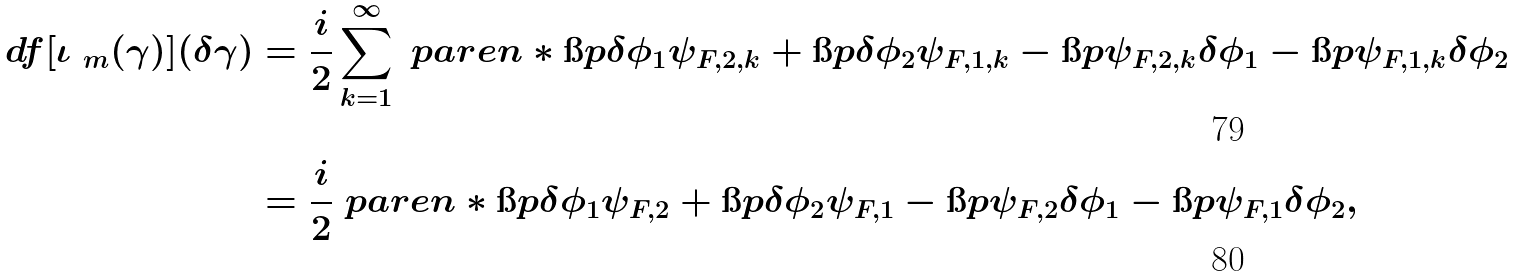Convert formula to latex. <formula><loc_0><loc_0><loc_500><loc_500>d f [ \iota _ { \ m } ( \gamma ) ] ( \delta \gamma ) & = \frac { i } { 2 } \sum _ { k = 1 } ^ { \infty } \ p a r e n * { \i p { \delta \phi _ { 1 } } { \psi _ { F , 2 , k } } + \i p { \delta \phi _ { 2 } } { \psi _ { F , 1 , k } } - \i p { \psi _ { F , 2 , k } } { \delta \phi _ { 1 } } - \i p { \psi _ { F , 1 , k } } { \delta \phi _ { 2 } } } \\ & = \frac { i } { 2 } \ p a r e n * { \i p { \delta \phi _ { 1 } } { \psi _ { F , 2 } } + \i p { \delta \phi _ { 2 } } { \psi _ { F , 1 } } - \i p { \psi _ { F , 2 } } { \delta \phi _ { 1 } } - \i p { \psi _ { F , 1 } } { \delta \phi _ { 2 } } } ,</formula> 